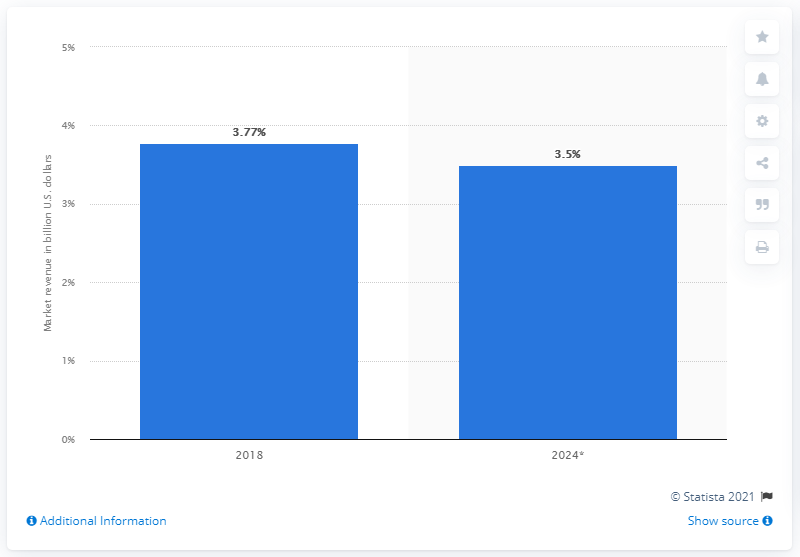Indicate a few pertinent items in this graphic. The estimated global revenue of the antivirus software market by 2024 is expected to be approximately 3.5... 